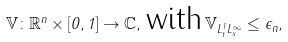Convert formula to latex. <formula><loc_0><loc_0><loc_500><loc_500>\mathbb { V } \colon \mathbb { R } ^ { n } \times [ 0 , 1 ] \to \mathbb { C } , \, \text {with} \, \| \mathbb { V } \| _ { L ^ { 1 } _ { t } L ^ { \infty } _ { x } } \leq \epsilon _ { n } ,</formula> 